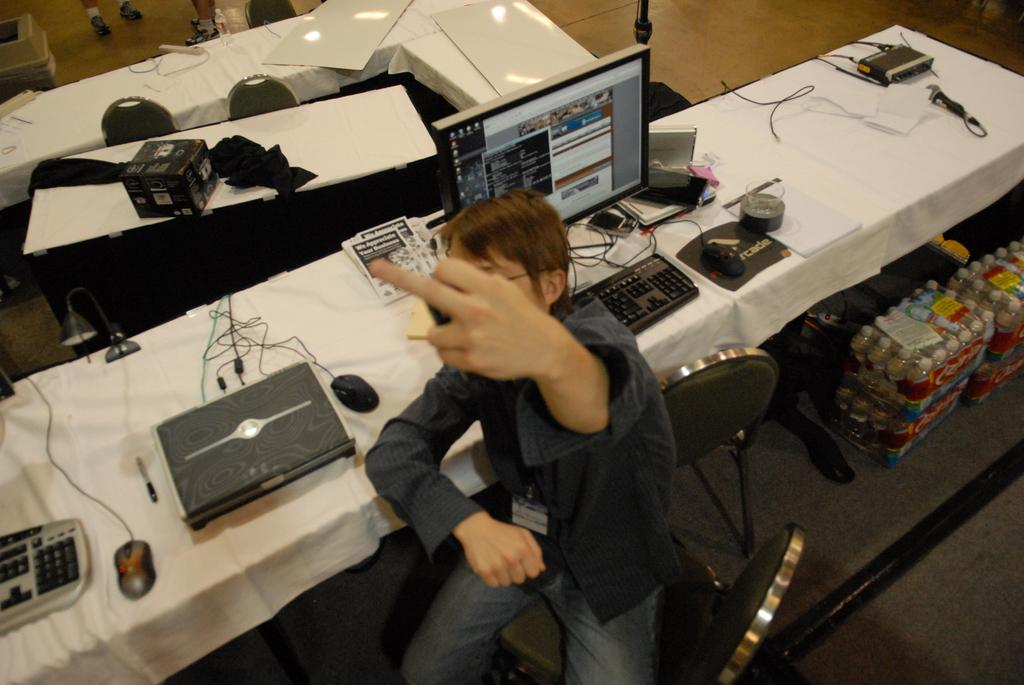What is the person in the image doing? The person is sitting on a chair in the image. What type of furniture is present in the image? Desktops are visible in the image. What accessories are used for computer mice in the image? Mouse pads are visible in the image. What connects the devices in the image? Cables are present in the image. What reading materials are in the image? There are books in the image. What writing instruments are visible in the image? Pens are visible in the image. What type of packaging is present in the image? Cardboard cartons are in the image. What type of containers are present in the image? Disposal bottles packed in covers are present in the image. How many frogs are sitting on the person's lap in the image? There are no frogs present in the image. What type of car is parked next to the person in the image? There is no car present in the image. 